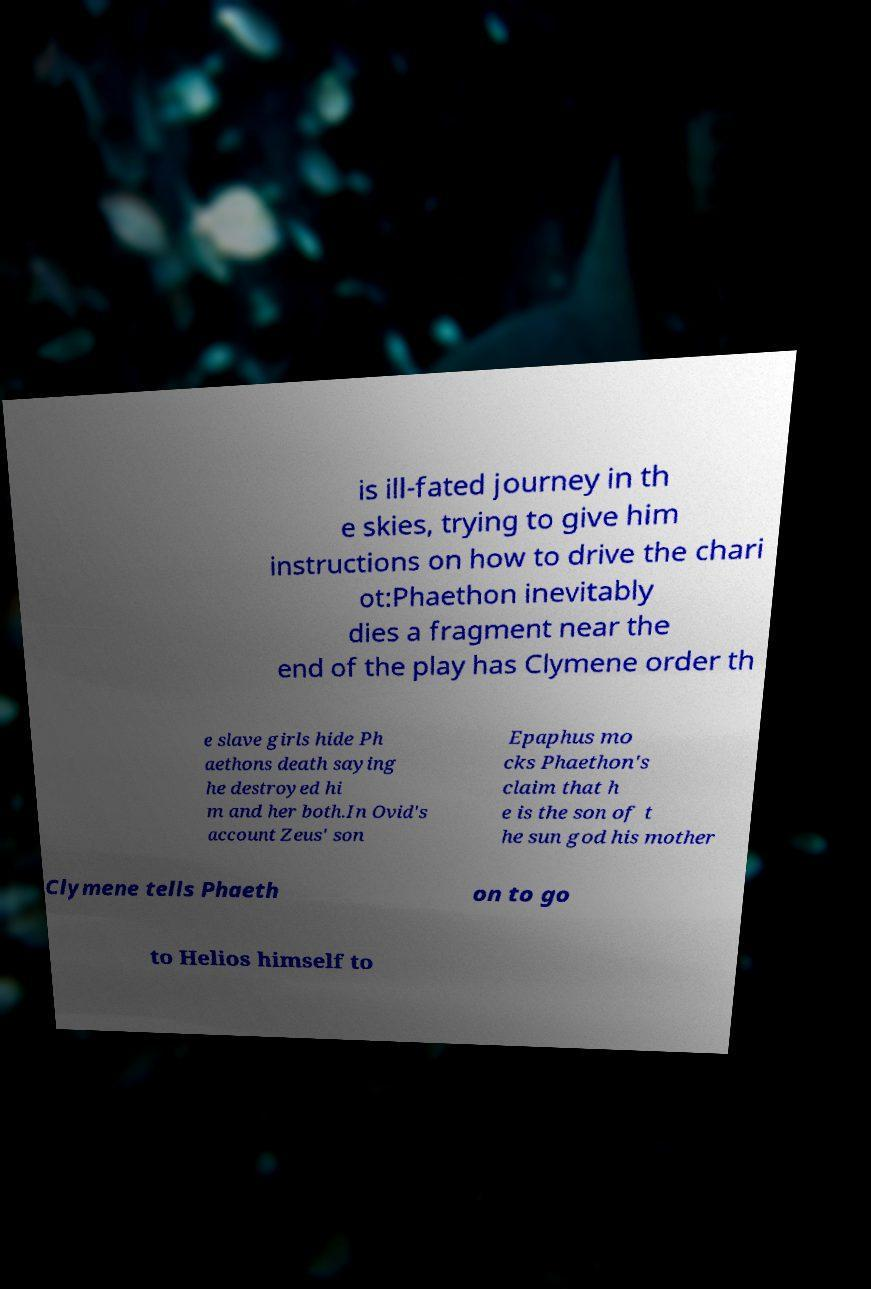Please identify and transcribe the text found in this image. is ill-fated journey in th e skies, trying to give him instructions on how to drive the chari ot:Phaethon inevitably dies a fragment near the end of the play has Clymene order th e slave girls hide Ph aethons death saying he destroyed hi m and her both.In Ovid's account Zeus' son Epaphus mo cks Phaethon's claim that h e is the son of t he sun god his mother Clymene tells Phaeth on to go to Helios himself to 